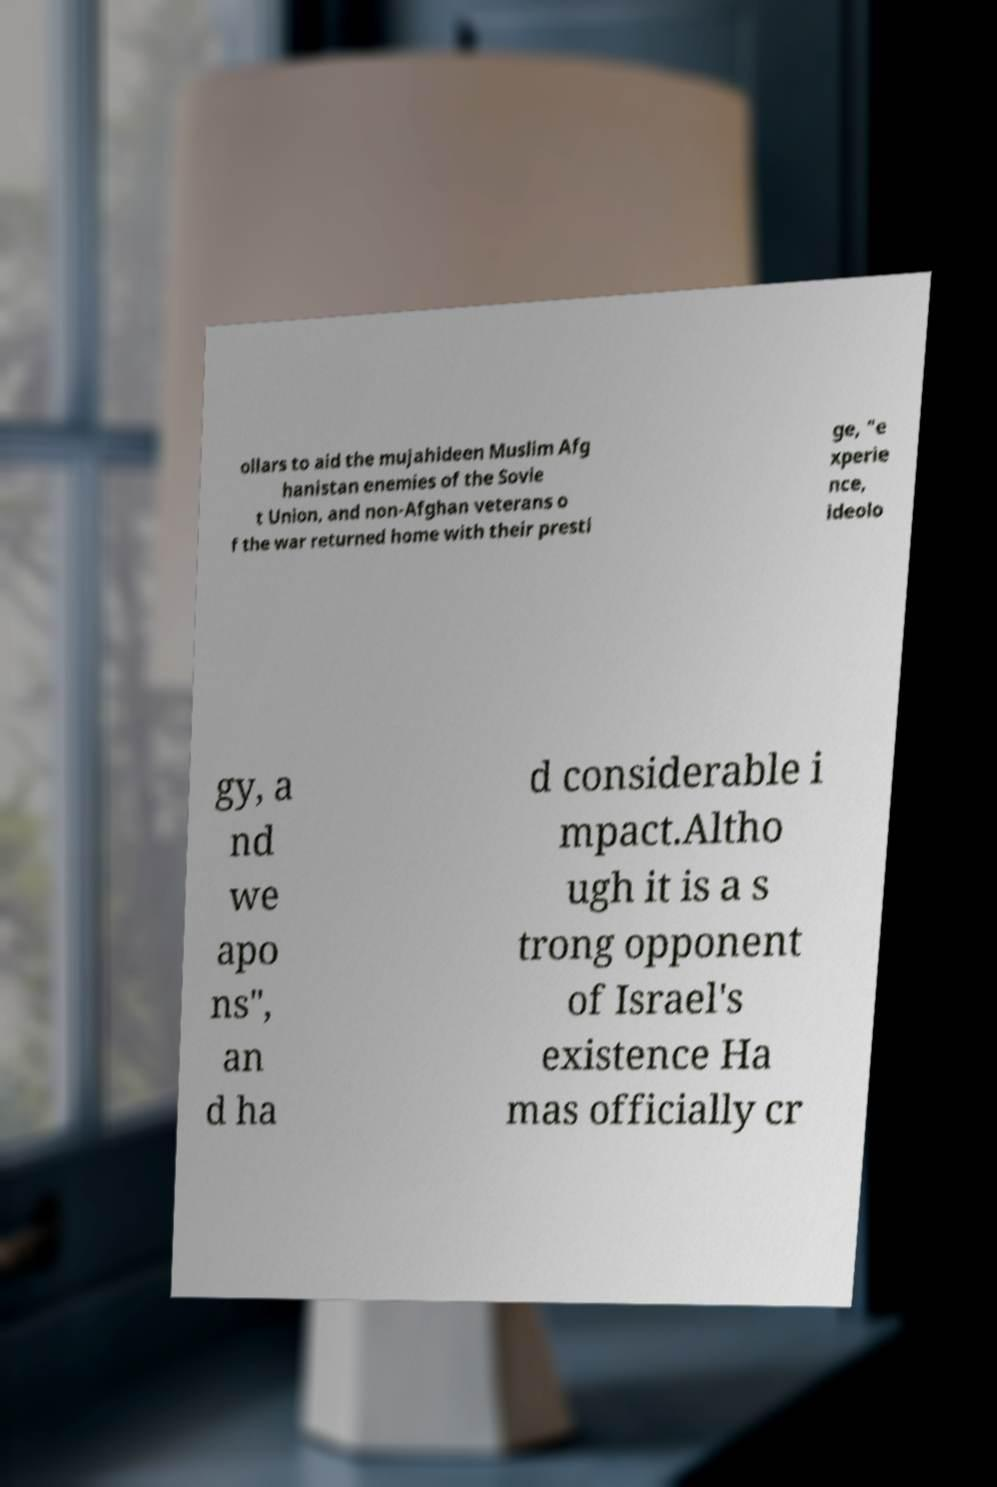I need the written content from this picture converted into text. Can you do that? ollars to aid the mujahideen Muslim Afg hanistan enemies of the Sovie t Union, and non-Afghan veterans o f the war returned home with their presti ge, "e xperie nce, ideolo gy, a nd we apo ns", an d ha d considerable i mpact.Altho ugh it is a s trong opponent of Israel's existence Ha mas officially cr 